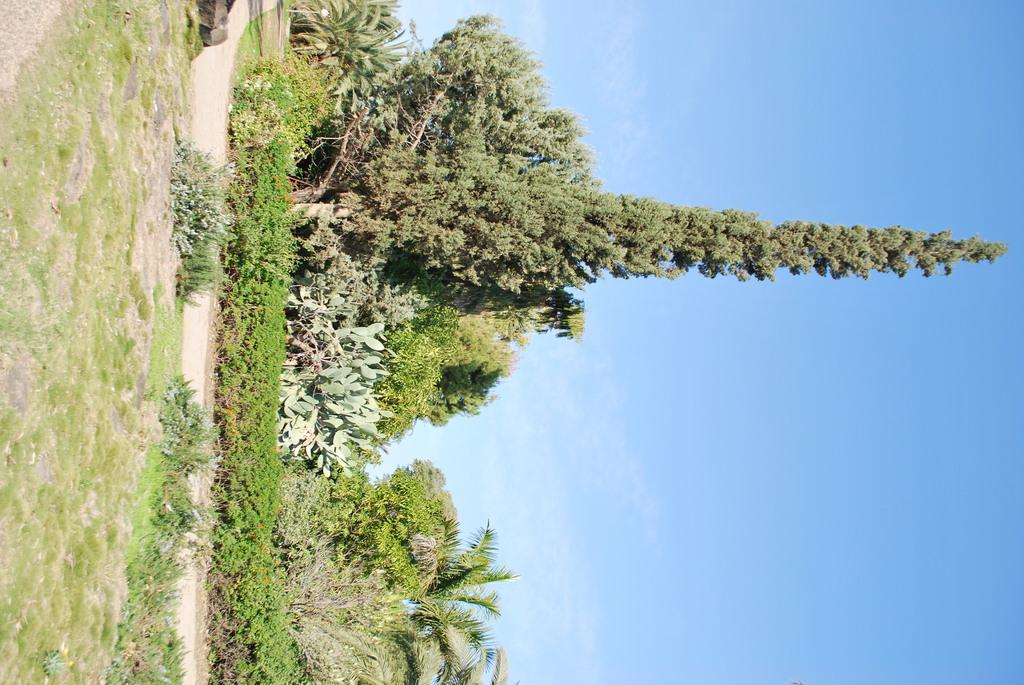Where was the picture taken? The picture was clicked outside. What can be seen in the foreground of the image? There is green grass, plants, and trees in the foreground of the image. What is visible on the ground in the foreground of the image? The ground is visible in the foreground of the image. What can be seen in the background of the image? The sky is visible in the background of the image. Is there a wound visible on any of the plants in the image? There is no indication of a wound on any of the plants in the image. What type of event is taking place in the image? There is no event taking place in the image; it is a still photograph of an outdoor scene. 